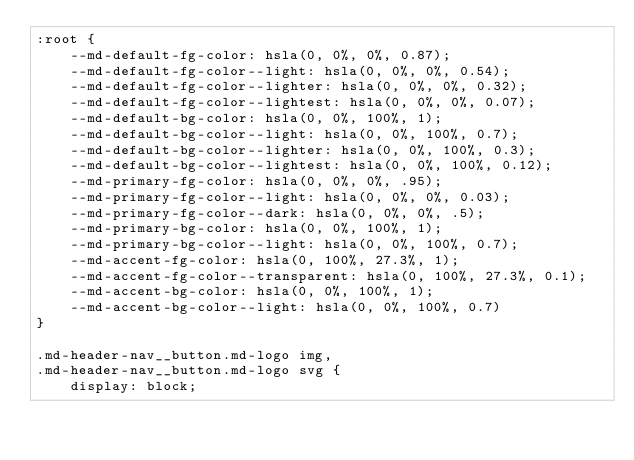Convert code to text. <code><loc_0><loc_0><loc_500><loc_500><_CSS_>:root {
	--md-default-fg-color: hsla(0, 0%, 0%, 0.87);
	--md-default-fg-color--light: hsla(0, 0%, 0%, 0.54);
	--md-default-fg-color--lighter: hsla(0, 0%, 0%, 0.32);
	--md-default-fg-color--lightest: hsla(0, 0%, 0%, 0.07);
	--md-default-bg-color: hsla(0, 0%, 100%, 1);
	--md-default-bg-color--light: hsla(0, 0%, 100%, 0.7);
	--md-default-bg-color--lighter: hsla(0, 0%, 100%, 0.3);
	--md-default-bg-color--lightest: hsla(0, 0%, 100%, 0.12);
	--md-primary-fg-color: hsla(0, 0%, 0%, .95);
	--md-primary-fg-color--light: hsla(0, 0%, 0%, 0.03);
	--md-primary-fg-color--dark: hsla(0, 0%, 0%, .5);
	--md-primary-bg-color: hsla(0, 0%, 100%, 1);
	--md-primary-bg-color--light: hsla(0, 0%, 100%, 0.7);
	--md-accent-fg-color: hsla(0, 100%, 27.3%, 1);
	--md-accent-fg-color--transparent: hsla(0, 100%, 27.3%, 0.1);
	--md-accent-bg-color: hsla(0, 0%, 100%, 1);
	--md-accent-bg-color--light: hsla(0, 0%, 100%, 0.7)
}

.md-header-nav__button.md-logo img,
.md-header-nav__button.md-logo svg {
	display: block;</code> 